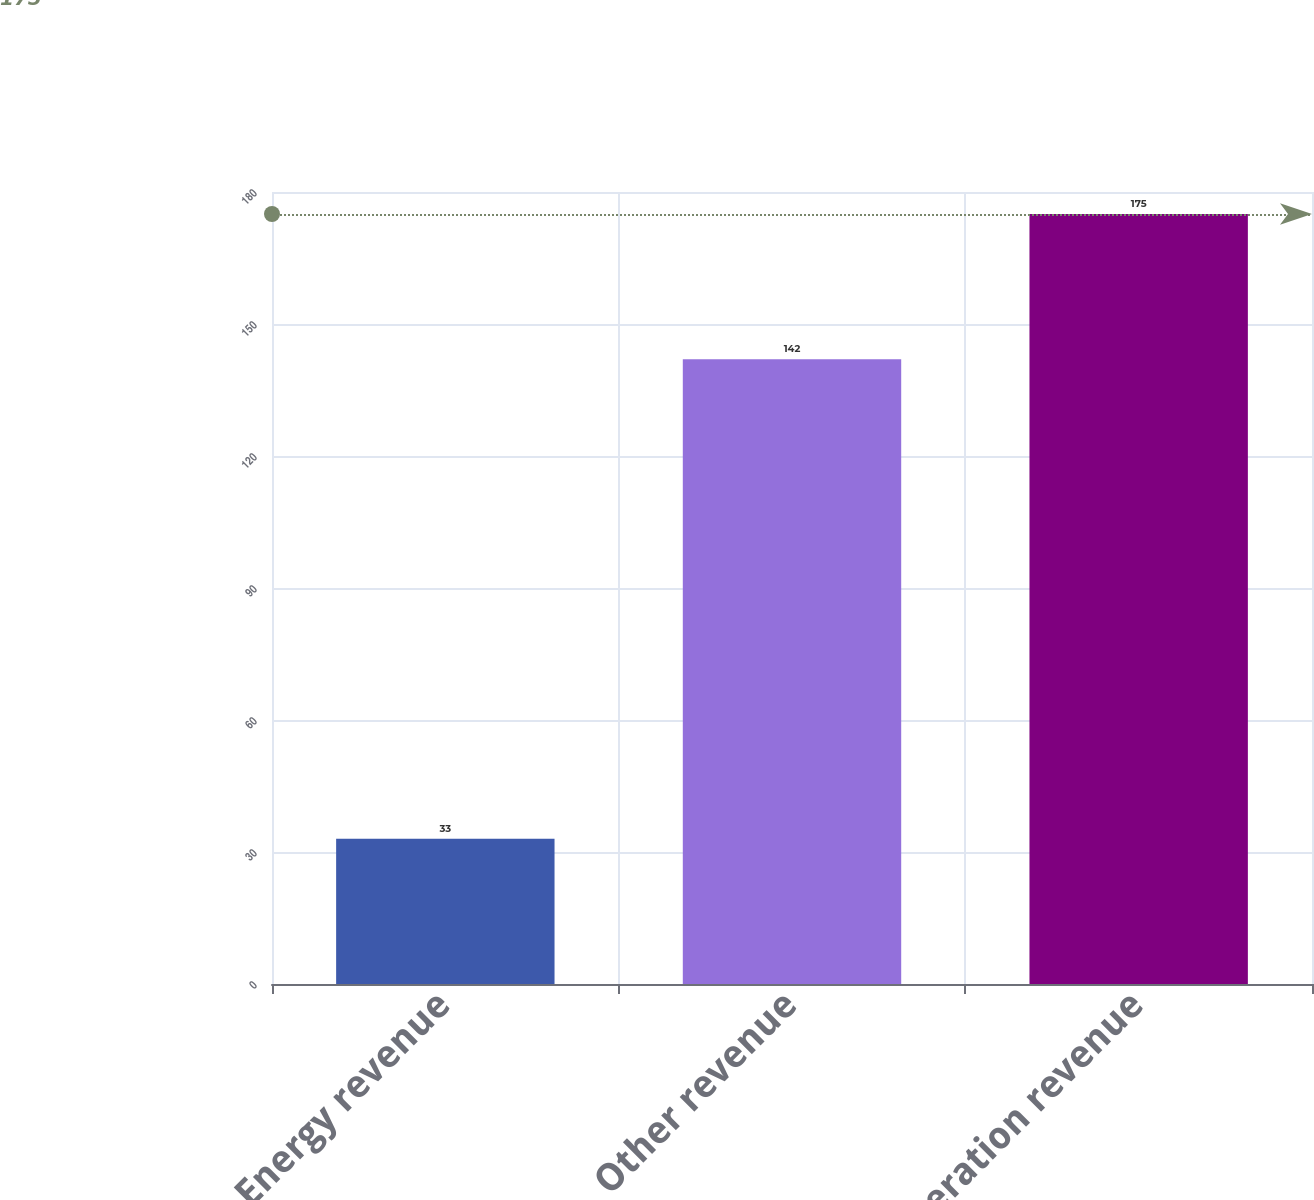Convert chart. <chart><loc_0><loc_0><loc_500><loc_500><bar_chart><fcel>Energy revenue<fcel>Other revenue<fcel>Generation revenue<nl><fcel>33<fcel>142<fcel>175<nl></chart> 